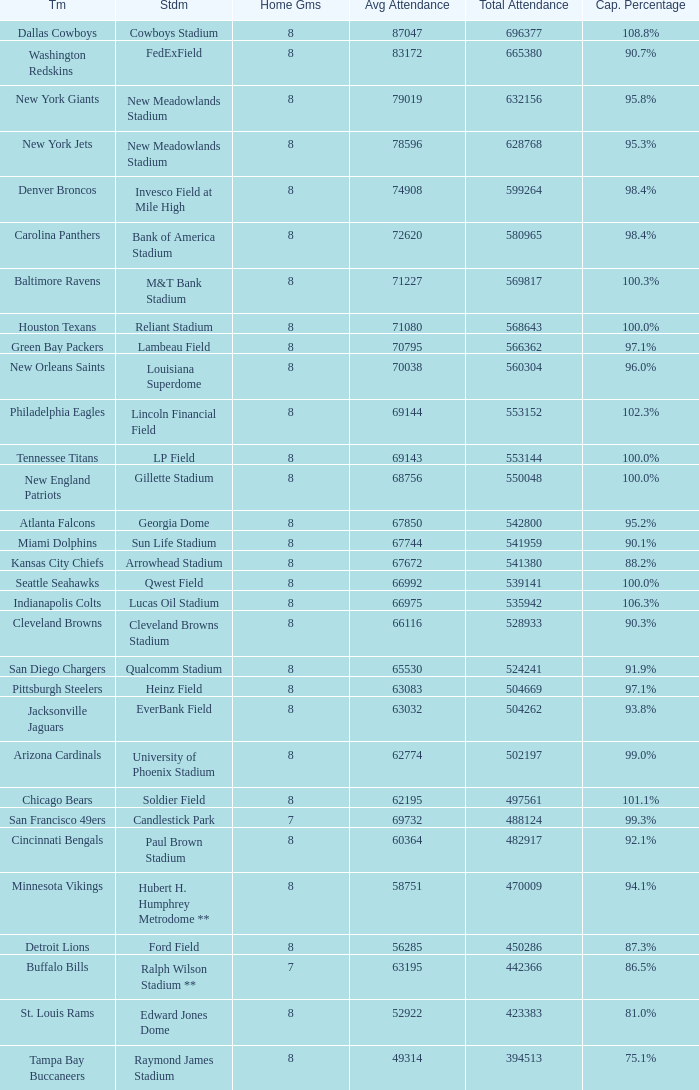What was the total attendance of the New York Giants? 632156.0. 